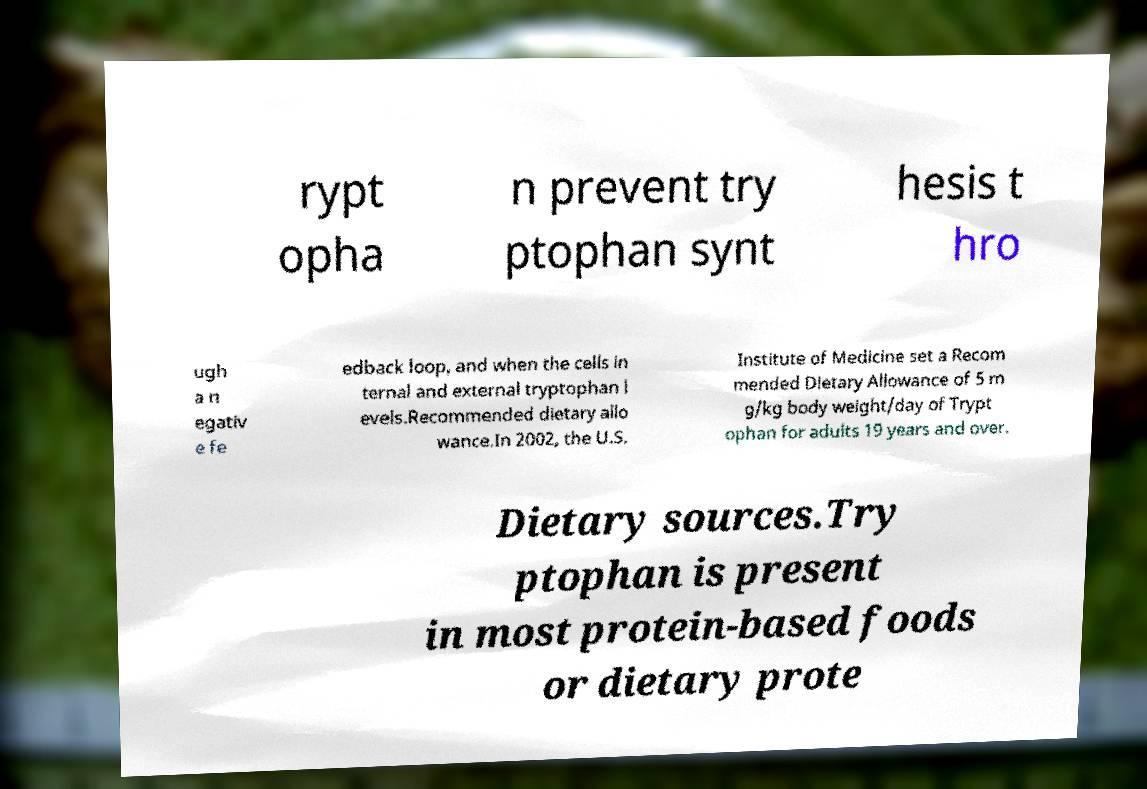Please read and relay the text visible in this image. What does it say? rypt opha n prevent try ptophan synt hesis t hro ugh a n egativ e fe edback loop, and when the cells in ternal and external tryptophan l evels.Recommended dietary allo wance.In 2002, the U.S. Institute of Medicine set a Recom mended Dietary Allowance of 5 m g/kg body weight/day of Trypt ophan for adults 19 years and over. Dietary sources.Try ptophan is present in most protein-based foods or dietary prote 